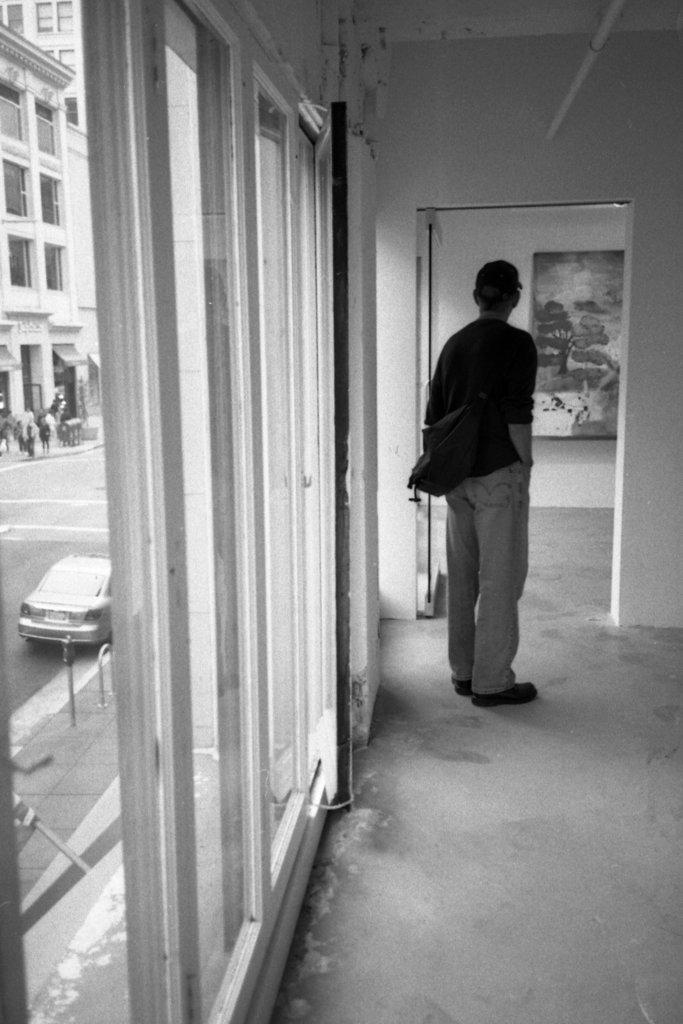Describe this image in one or two sentences. In this picture there is a man standing on the floor and carrying a bag and we can see glass, through glass we can see car on the road, rods, people and buildings. In the background of the image we can see a board on the wall. 